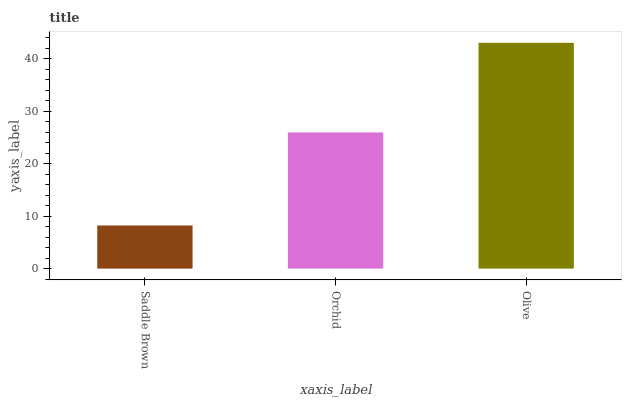Is Orchid the minimum?
Answer yes or no. No. Is Orchid the maximum?
Answer yes or no. No. Is Orchid greater than Saddle Brown?
Answer yes or no. Yes. Is Saddle Brown less than Orchid?
Answer yes or no. Yes. Is Saddle Brown greater than Orchid?
Answer yes or no. No. Is Orchid less than Saddle Brown?
Answer yes or no. No. Is Orchid the high median?
Answer yes or no. Yes. Is Orchid the low median?
Answer yes or no. Yes. Is Olive the high median?
Answer yes or no. No. Is Saddle Brown the low median?
Answer yes or no. No. 